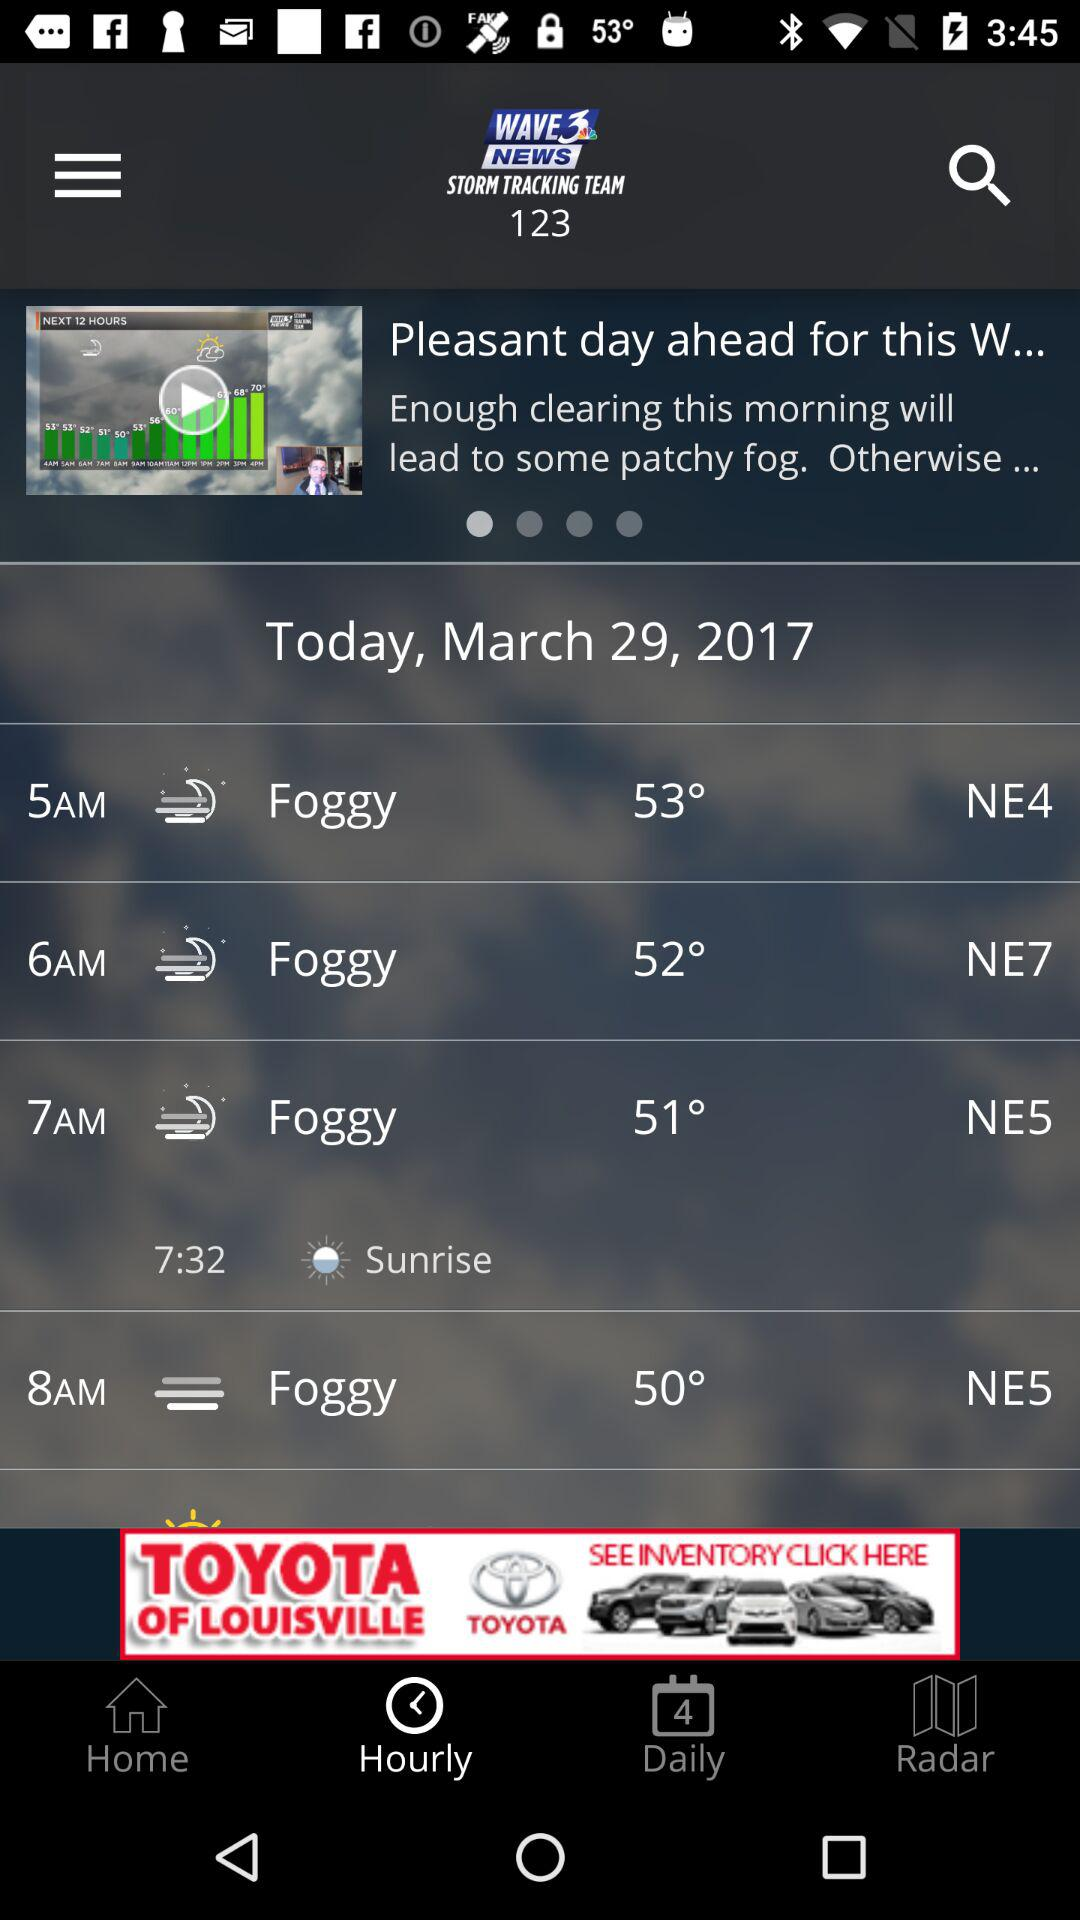What is the wind direction at 8 am?
Answer the question using a single word or phrase. NE5 